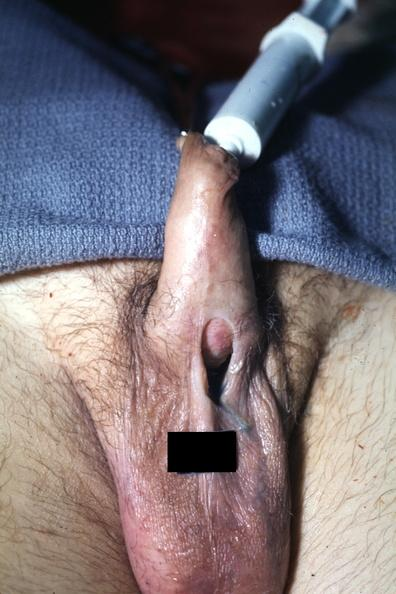what is present?
Answer the question using a single word or phrase. Penis 